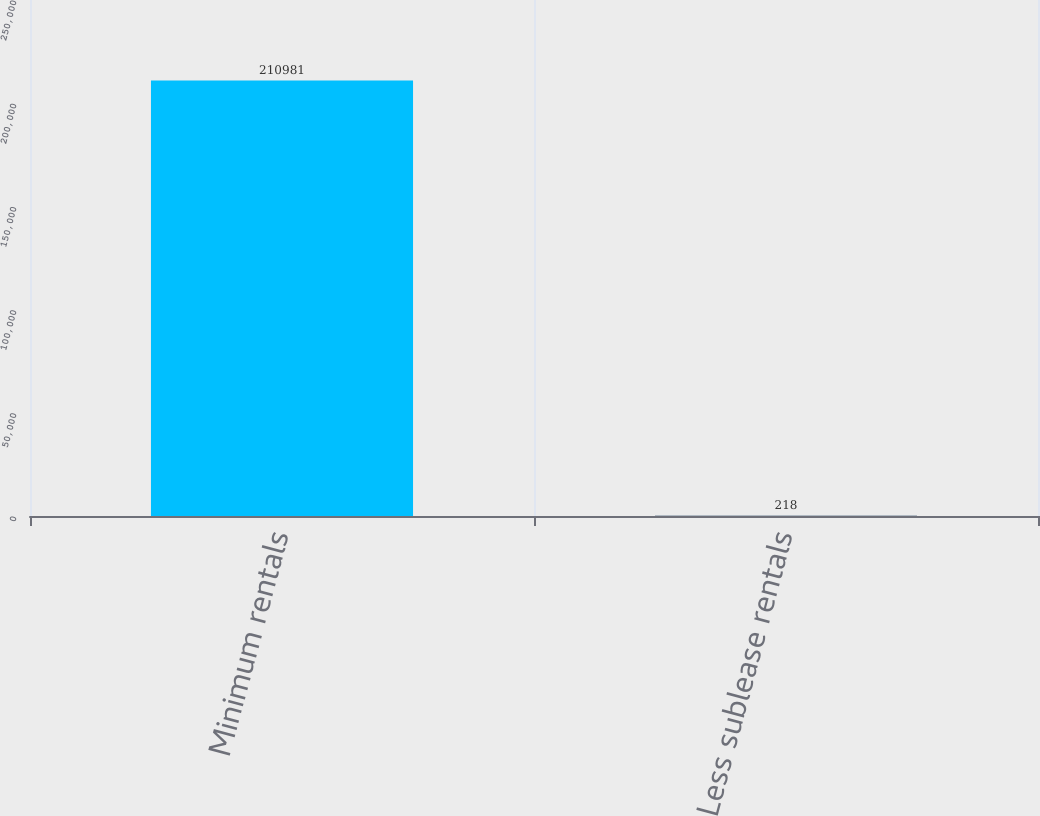<chart> <loc_0><loc_0><loc_500><loc_500><bar_chart><fcel>Minimum rentals<fcel>Less sublease rentals<nl><fcel>210981<fcel>218<nl></chart> 